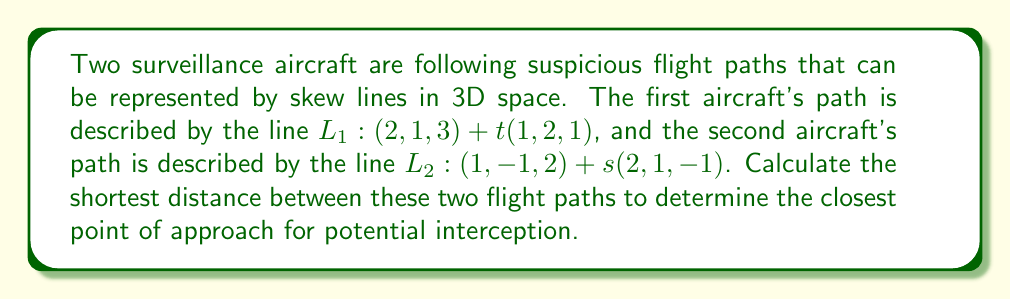Can you answer this question? To find the shortest distance between two skew lines, we can follow these steps:

1) First, we need to find the direction vectors of the two lines:
   $\vec{a} = (1, 2, 1)$ for $L_1$
   $\vec{b} = (2, 1, -1)$ for $L_2$

2) Calculate the cross product of these direction vectors:
   $$\vec{n} = \vec{a} \times \vec{b} = \begin{vmatrix}
   \hat{i} & \hat{j} & \hat{k} \\
   1 & 2 & 1 \\
   2 & 1 & -1
   \end{vmatrix} = (-3)\hat{i} + (3)\hat{j} + (-3)\hat{k} = (-3, 3, -3)$$

3) Find a vector connecting any point on $L_1$ to any point on $L_2$:
   $\vec{c} = (1, -1, 2) - (2, 1, 3) = (-1, -2, -1)$

4) The shortest distance is given by the formula:
   $$d = \frac{|\vec{c} \cdot \vec{n}|}{|\vec{n}|}$$

5) Calculate the dot product $\vec{c} \cdot \vec{n}$:
   $\vec{c} \cdot \vec{n} = (-1)(-3) + (-2)(3) + (-1)(-3) = 3 - 6 + 3 = 0$

6) Calculate the magnitude of $\vec{n}$:
   $|\vec{n}| = \sqrt{(-3)^2 + 3^2 + (-3)^2} = \sqrt{27} = 3\sqrt{3}$

7) Finally, calculate the shortest distance:
   $$d = \frac{|0|}{3\sqrt{3}} = 0$$

This result indicates that the two flight paths intersect, meaning there is a point where the aircraft's paths cross.

[asy]
import three;
size(200);
currentprojection=perspective(6,3,2);

draw((0,0,0)--(3,0,0),gray+dashed);
draw((0,0,0)--(0,3,0),gray+dashed);
draw((0,0,0)--(0,0,3),gray+dashed);

draw((2,1,3)--(3,3,4),blue,Arrow3);
draw((1,-1,2)--(3,0,1),red,Arrow3);

dot((2,1,3),blue);
dot((1,-1,2),red);

label("$L_1$",(3,3,4),N);
label("$L_2$",(3,0,1),S);
[/asy]
Answer: The shortest distance between the two flight paths is 0 units, indicating that the paths intersect at a point. 